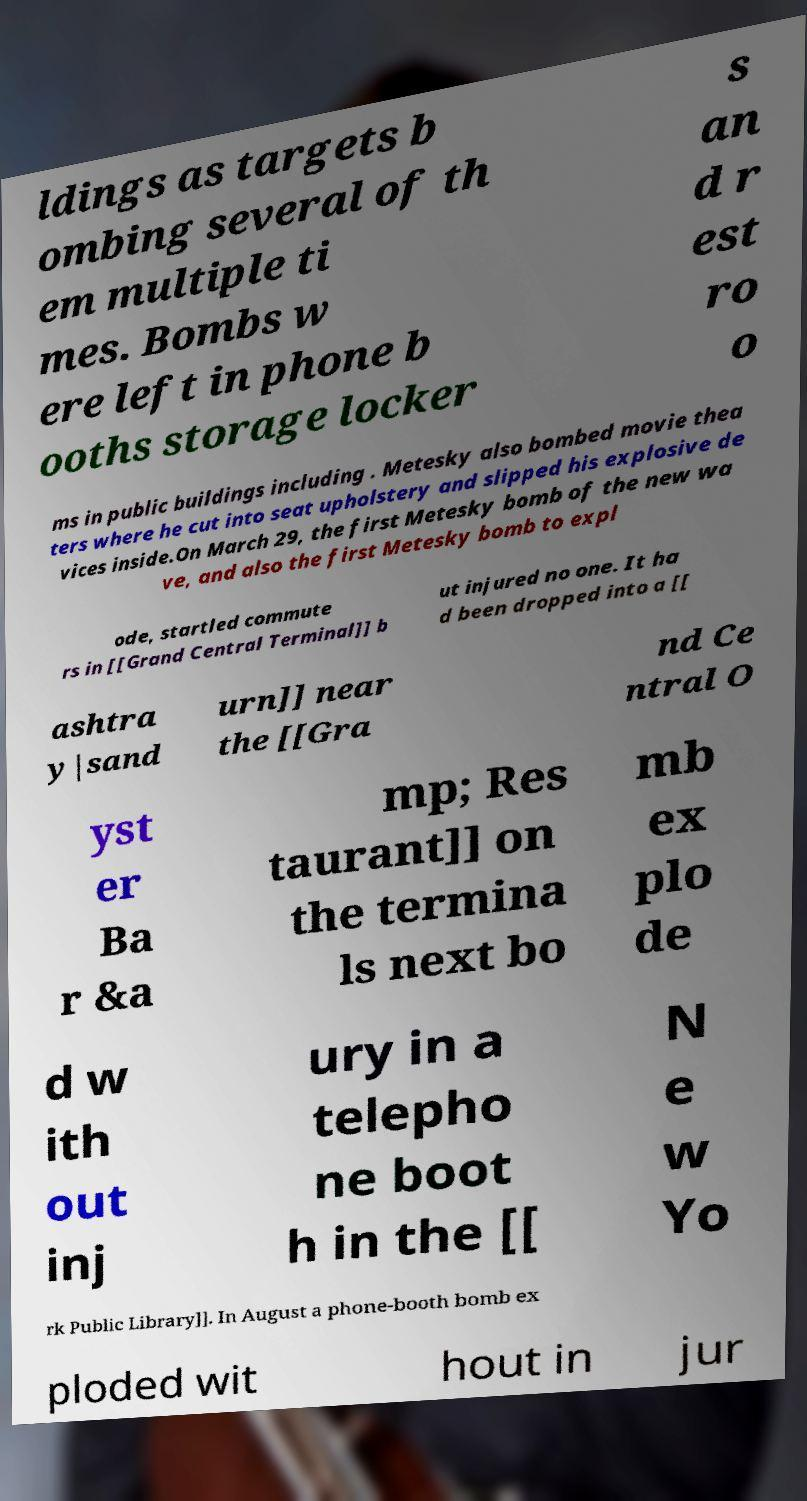Please identify and transcribe the text found in this image. ldings as targets b ombing several of th em multiple ti mes. Bombs w ere left in phone b ooths storage locker s an d r est ro o ms in public buildings including . Metesky also bombed movie thea ters where he cut into seat upholstery and slipped his explosive de vices inside.On March 29, the first Metesky bomb of the new wa ve, and also the first Metesky bomb to expl ode, startled commute rs in [[Grand Central Terminal]] b ut injured no one. It ha d been dropped into a [[ ashtra y|sand urn]] near the [[Gra nd Ce ntral O yst er Ba r &a mp; Res taurant]] on the termina ls next bo mb ex plo de d w ith out inj ury in a telepho ne boot h in the [[ N e w Yo rk Public Library]]. In August a phone-booth bomb ex ploded wit hout in jur 